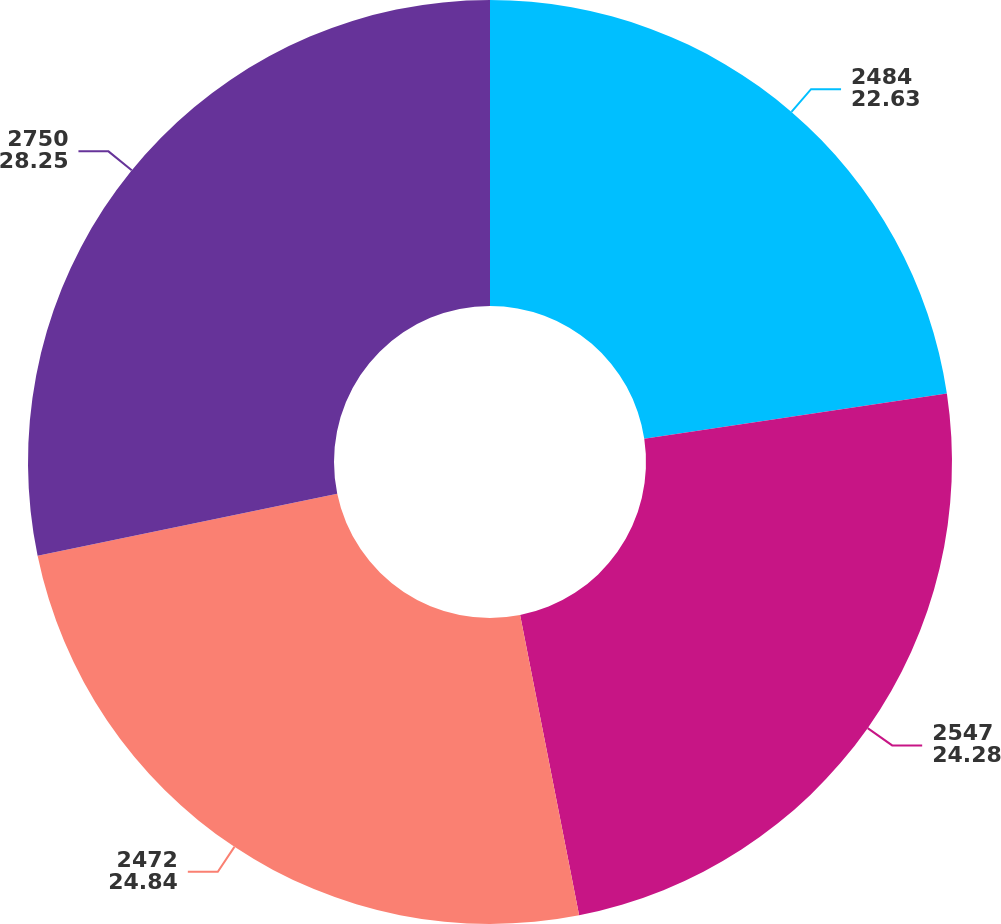<chart> <loc_0><loc_0><loc_500><loc_500><pie_chart><fcel>2484<fcel>2547<fcel>2472<fcel>2750<nl><fcel>22.63%<fcel>24.28%<fcel>24.84%<fcel>28.25%<nl></chart> 